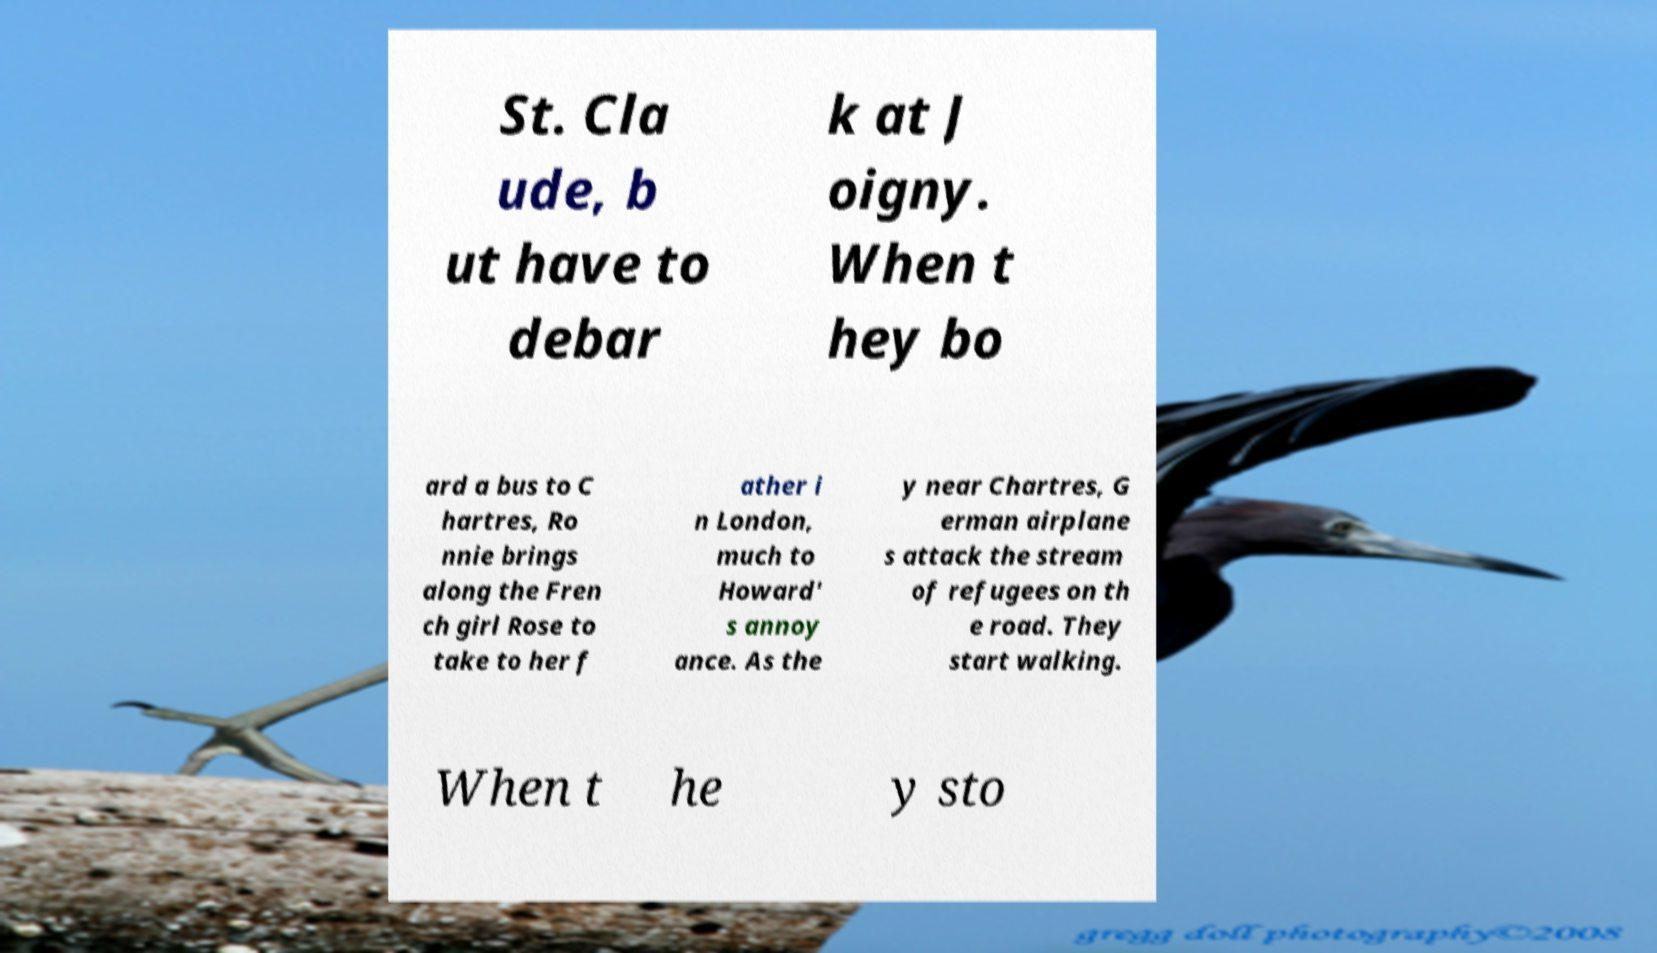Please identify and transcribe the text found in this image. St. Cla ude, b ut have to debar k at J oigny. When t hey bo ard a bus to C hartres, Ro nnie brings along the Fren ch girl Rose to take to her f ather i n London, much to Howard' s annoy ance. As the y near Chartres, G erman airplane s attack the stream of refugees on th e road. They start walking. When t he y sto 